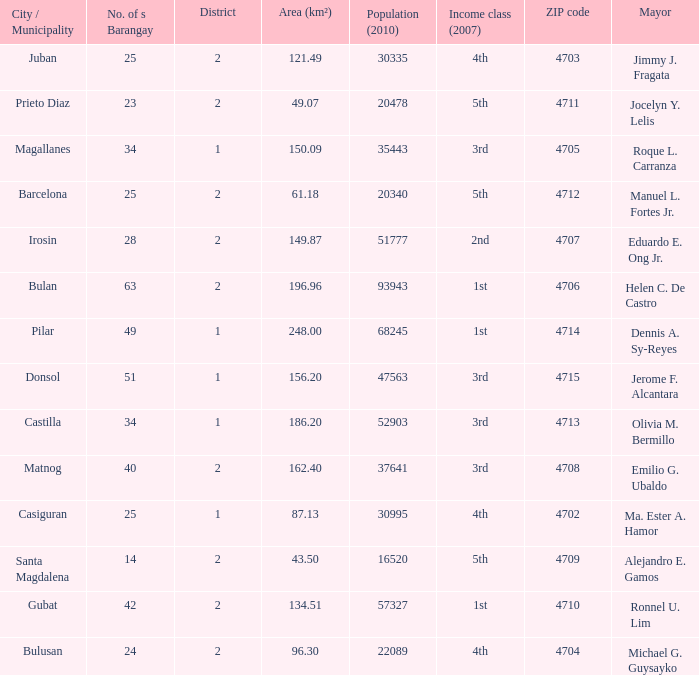What are all the profits elegance (2007) in which mayor is ma. Ester a. Hamor 4th. 